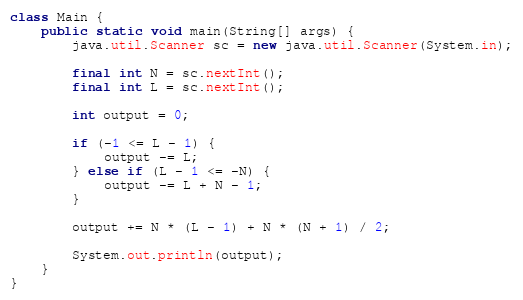Convert code to text. <code><loc_0><loc_0><loc_500><loc_500><_Java_>class Main {
    public static void main(String[] args) {
        java.util.Scanner sc = new java.util.Scanner(System.in);

        final int N = sc.nextInt();
        final int L = sc.nextInt();

        int output = 0;

        if (-1 <= L - 1) {
            output -= L;
        } else if (L - 1 <= -N) {
            output -= L + N - 1;
        }

        output += N * (L - 1) + N * (N + 1) / 2;

        System.out.println(output);
    }
}</code> 